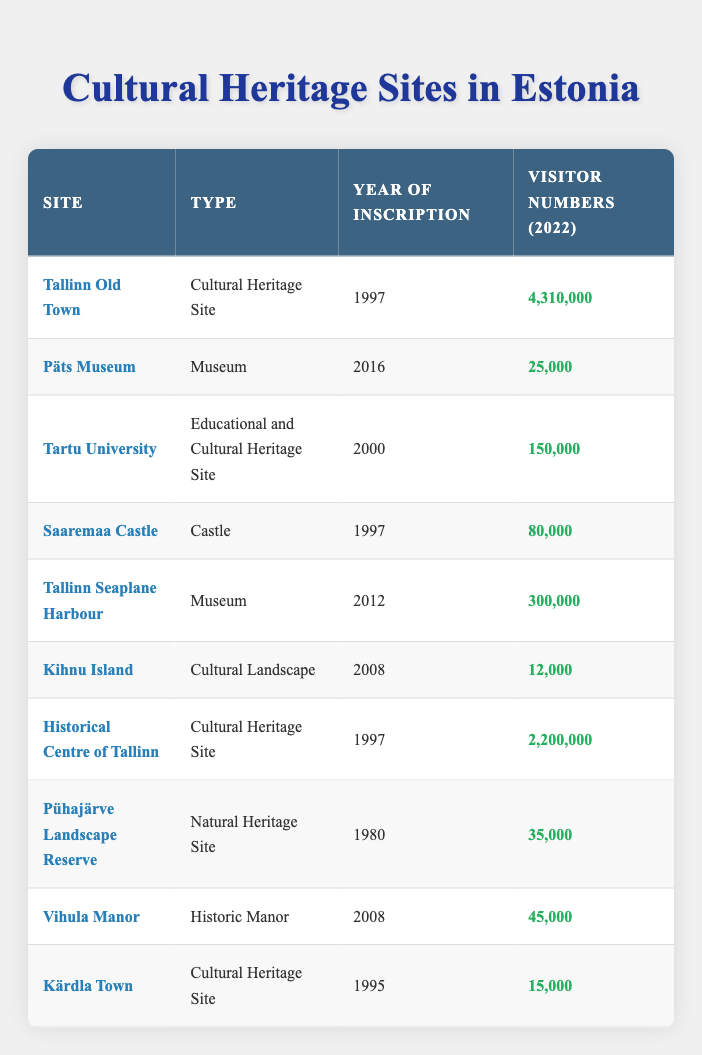What is the visitor number for Tallinn Old Town in 2022? The table shows that the visitor number for Tallinn Old Town in 2022 is listed under the "Visitor Numbers (2022)" column. The value is provided directly next to the site name.
Answer: 4,310,000 Which site received the least number of visitors in 2022? By examining the "Visitor Numbers (2022)" column and identifying the lowest value, Kihnu Island with 12,000 visitors is identified as receiving the least number of visitors.
Answer: Kihnu Island How many total visitors did the cultural heritage sites receive in 2022? The total can be calculated by summing the visitor numbers for all cultural heritage sites: 4,310,000 (Tallinn Old Town) + 2,200,000 (Historical Centre of Tallinn) + 150,000 (Tartu University) + 80,000 (Saaremaa Castle) + 15,000 (Kärdla Town) = 6,755,000.
Answer: 6,755,000 Was Tartu University inscribed in 1997? Checking the year of inscription for Tartu University in the table, it shows that it was inscribed in 2000, thus the statement is false.
Answer: No What is the difference in visitor numbers between Tallinn Old Town and the Historical Centre of Tallinn in 2022? First, identify the visitor numbers: Tallinn Old Town has 4,310,000 visitors and the Historical Centre of Tallinn has 2,200,000. The difference is calculated as 4,310,000 - 2,200,000 = 2,110,000.
Answer: 2,110,000 Which site had more visitors, the Tallinn Seaplane Harbour or Saaremaa Castle, in 2022? The visitor numbers are compared: Tallinn Seaplane Harbour had 300,000 visitors and Saaremaa Castle had 80,000 visitors. Since 300,000 is greater than 80,000, the conclusion is based on this comparison.
Answer: Tallinn Seaplane Harbour What is the average number of visitors for all the listed sites in 2022? The average is calculated by first summing all visitor numbers (4,310,000 + 25,000 + 150,000 + 80,000 + 300,000 + 12,000 + 2,200,000 + 35,000 + 45,000 + 15,000 = 6,755,000) and dividing by the number of sites (10). So, 6,755,000 / 10 = 675,500.
Answer: 675,500 Is Kihnu Island a cultural heritage site? According to the table, Kihnu Island is categorized under "Cultural Landscape," which suggests it is related but does not classify it explicitly as a cultural heritage site per the main category listed. Therefore, the answer relies on the category details.
Answer: No If we combine visitor numbers from all museum sites, what is the total? Identify all museum entries from the table: Päts Museum (25,000) and Tallinn Seaplane Harbour (300,000). The total is calculated: 25,000 + 300,000 = 325,000.
Answer: 325,000 Which site had more visitors, Pühajärve Landscape Reserve or Vihula Manor? The respective visitor numbers are compared: Pühajärve Landscape Reserve had 35,000 visitors while Vihula Manor had 45,000. Since 45,000 is greater than 35,000, the answer is derived from this comparison.
Answer: Vihula Manor 